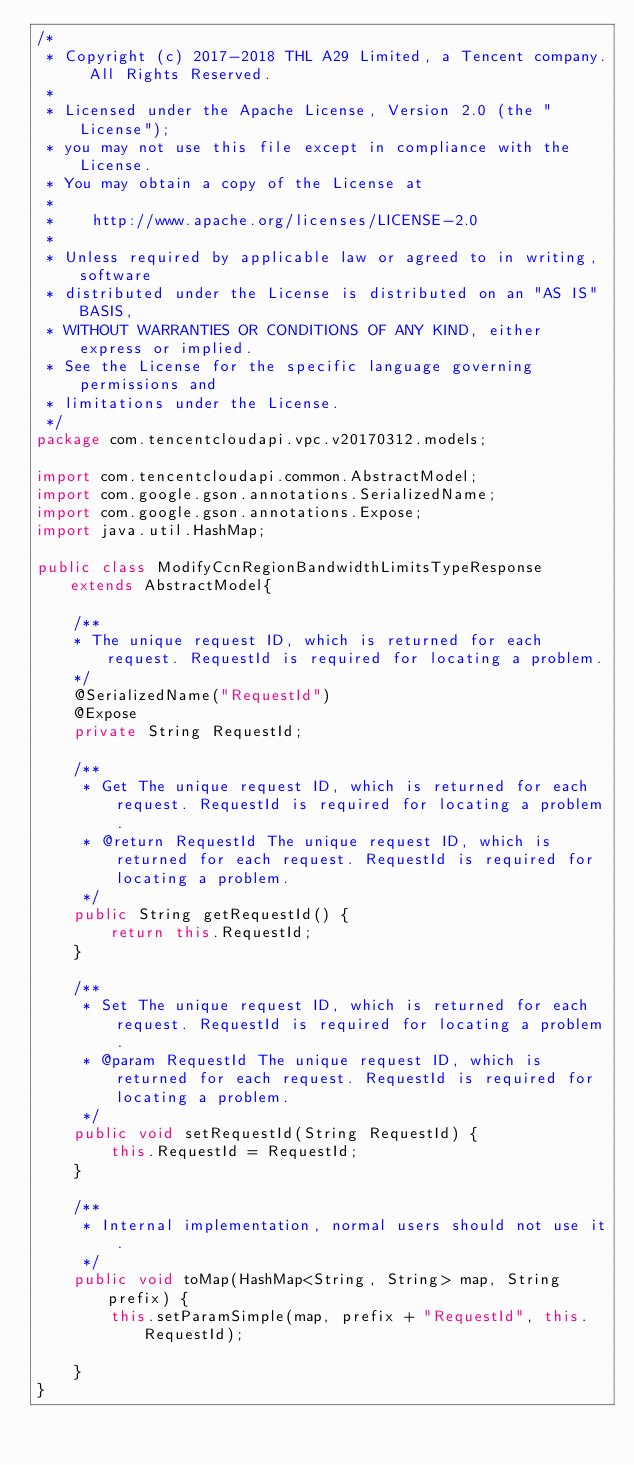<code> <loc_0><loc_0><loc_500><loc_500><_Java_>/*
 * Copyright (c) 2017-2018 THL A29 Limited, a Tencent company. All Rights Reserved.
 *
 * Licensed under the Apache License, Version 2.0 (the "License");
 * you may not use this file except in compliance with the License.
 * You may obtain a copy of the License at
 *
 *    http://www.apache.org/licenses/LICENSE-2.0
 *
 * Unless required by applicable law or agreed to in writing, software
 * distributed under the License is distributed on an "AS IS" BASIS,
 * WITHOUT WARRANTIES OR CONDITIONS OF ANY KIND, either express or implied.
 * See the License for the specific language governing permissions and
 * limitations under the License.
 */
package com.tencentcloudapi.vpc.v20170312.models;

import com.tencentcloudapi.common.AbstractModel;
import com.google.gson.annotations.SerializedName;
import com.google.gson.annotations.Expose;
import java.util.HashMap;

public class ModifyCcnRegionBandwidthLimitsTypeResponse extends AbstractModel{

    /**
    * The unique request ID, which is returned for each request. RequestId is required for locating a problem.
    */
    @SerializedName("RequestId")
    @Expose
    private String RequestId;

    /**
     * Get The unique request ID, which is returned for each request. RequestId is required for locating a problem. 
     * @return RequestId The unique request ID, which is returned for each request. RequestId is required for locating a problem.
     */
    public String getRequestId() {
        return this.RequestId;
    }

    /**
     * Set The unique request ID, which is returned for each request. RequestId is required for locating a problem.
     * @param RequestId The unique request ID, which is returned for each request. RequestId is required for locating a problem.
     */
    public void setRequestId(String RequestId) {
        this.RequestId = RequestId;
    }

    /**
     * Internal implementation, normal users should not use it.
     */
    public void toMap(HashMap<String, String> map, String prefix) {
        this.setParamSimple(map, prefix + "RequestId", this.RequestId);

    }
}

</code> 